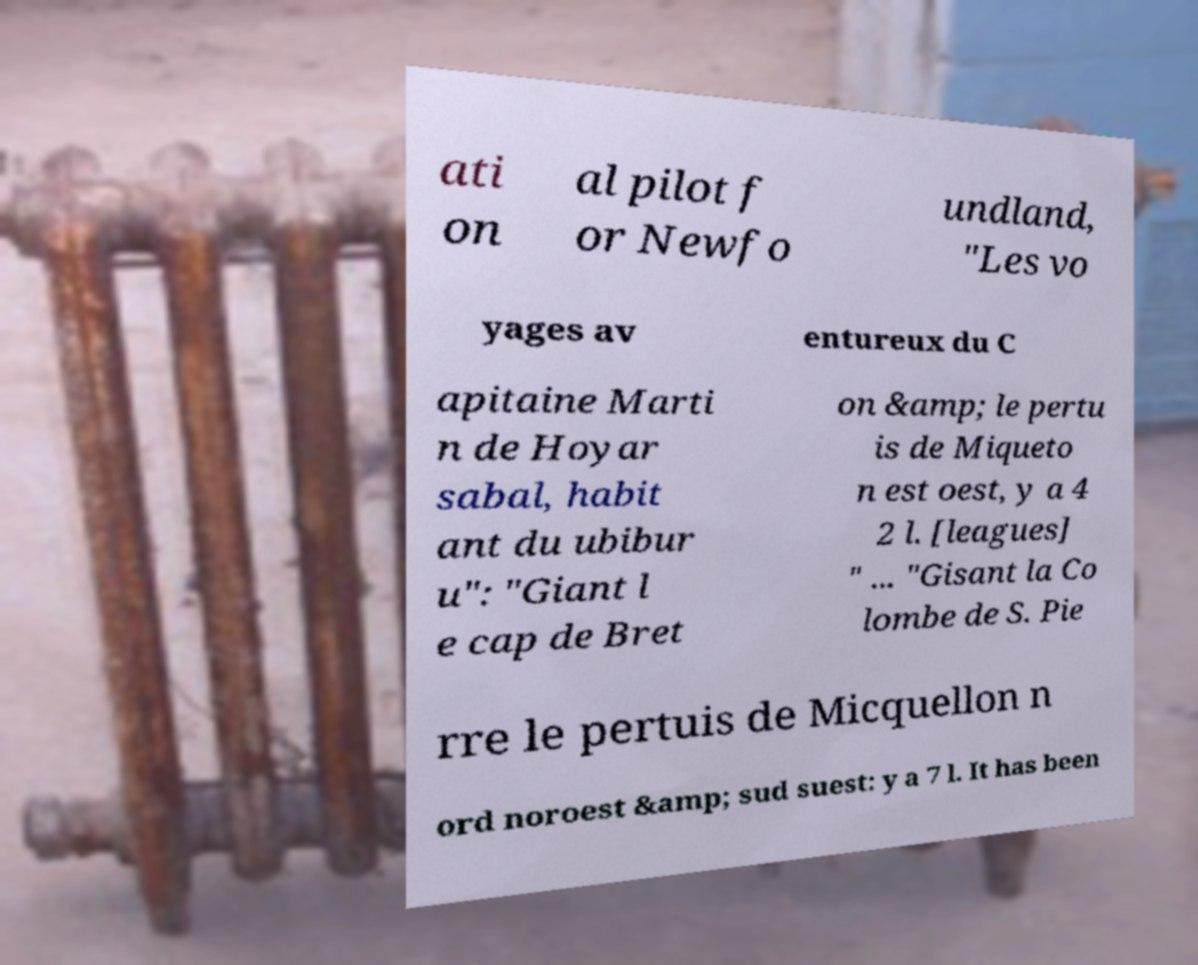Could you extract and type out the text from this image? ati on al pilot f or Newfo undland, "Les vo yages av entureux du C apitaine Marti n de Hoyar sabal, habit ant du ubibur u": "Giant l e cap de Bret on &amp; le pertu is de Miqueto n est oest, y a 4 2 l. [leagues] " ... "Gisant la Co lombe de S. Pie rre le pertuis de Micquellon n ord noroest &amp; sud suest: y a 7 l. It has been 